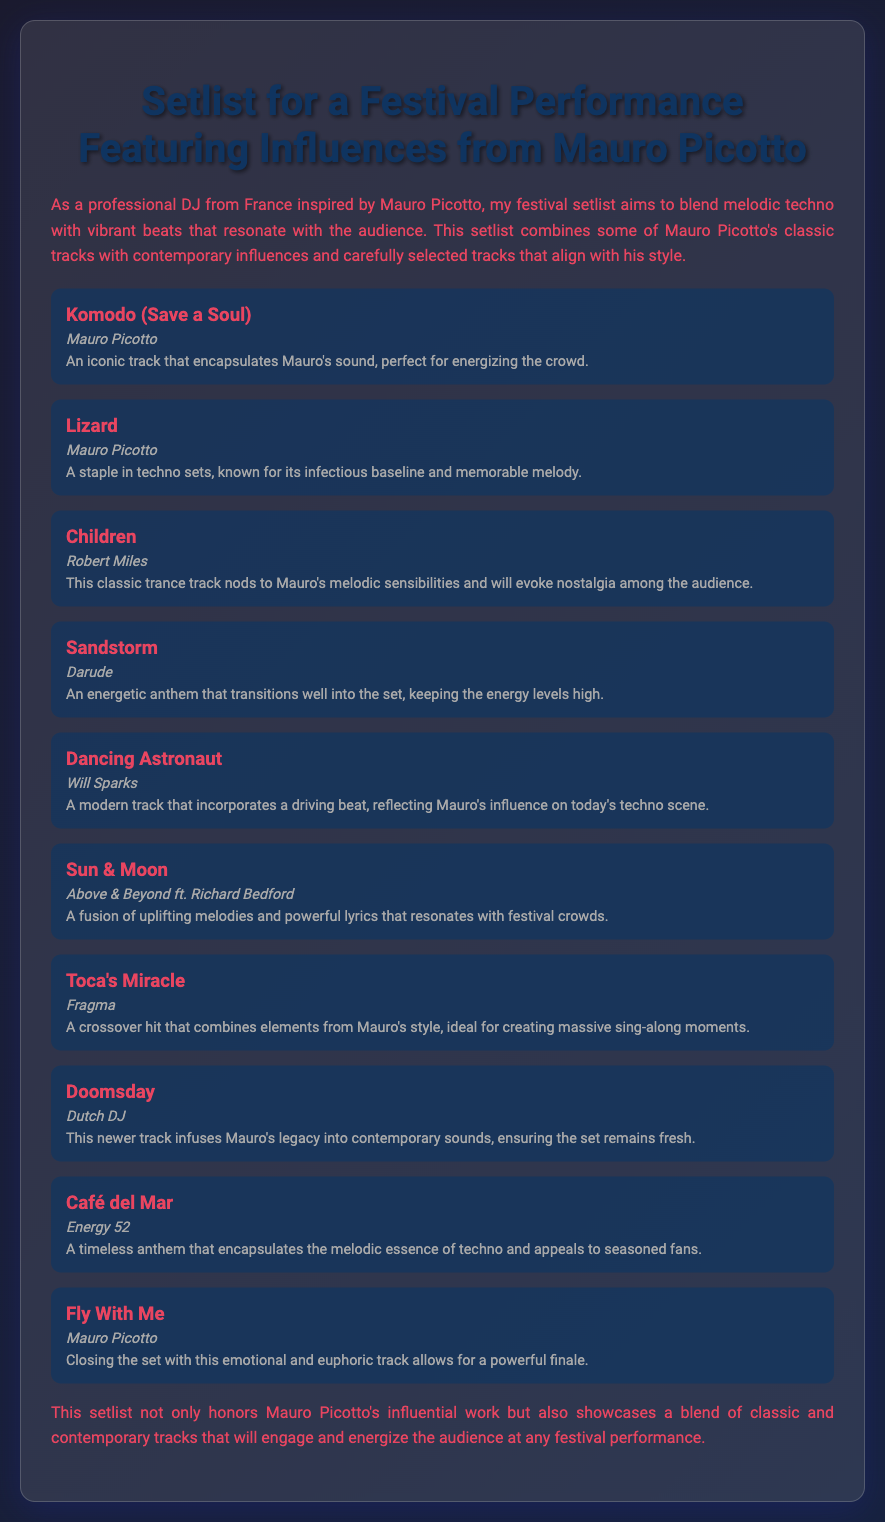What is the title of the document? The title of the document is presented prominently at the top, stating the theme of the setlist.
Answer: Setlist for a Festival Performance Featuring Influences from Mauro Picotto Who is the artist of the track "Lizard"? The document lists the artist associated with each track, and "Lizard" is attributed to Mauro Picotto.
Answer: Mauro Picotto What genre of music does the setlist primarily focus on? The introduction hints at the genre, emphasizing a blend of melodic techno and vibrant beats.
Answer: Melodic techno Which track is listed as the closing song? The last track mentioned in the setlist is provided as the conclusion of the performance.
Answer: Fly With Me How many tracks are included in the setlist? By counting the listed tracks in the setlist, the total can be determined.
Answer: 10 What is the name of the artist who performed "Children"? The document names the artist for each track and lists Robert Miles for "Children".
Answer: Robert Miles Which track is described as a timeless anthem? The description of the tracks gives insights into their significance, noting "Café del Mar" as timeless.
Answer: Café del Mar What is the style of the track "Dancing Astronaut"? The explanation in the document describes the characteristics of "Dancing Astronaut".
Answer: Driving beat Which artist features on "Sun & Moon"? The document states the featuring artist alongside the main artist for the song "Sun & Moon".
Answer: Richard Bedford 